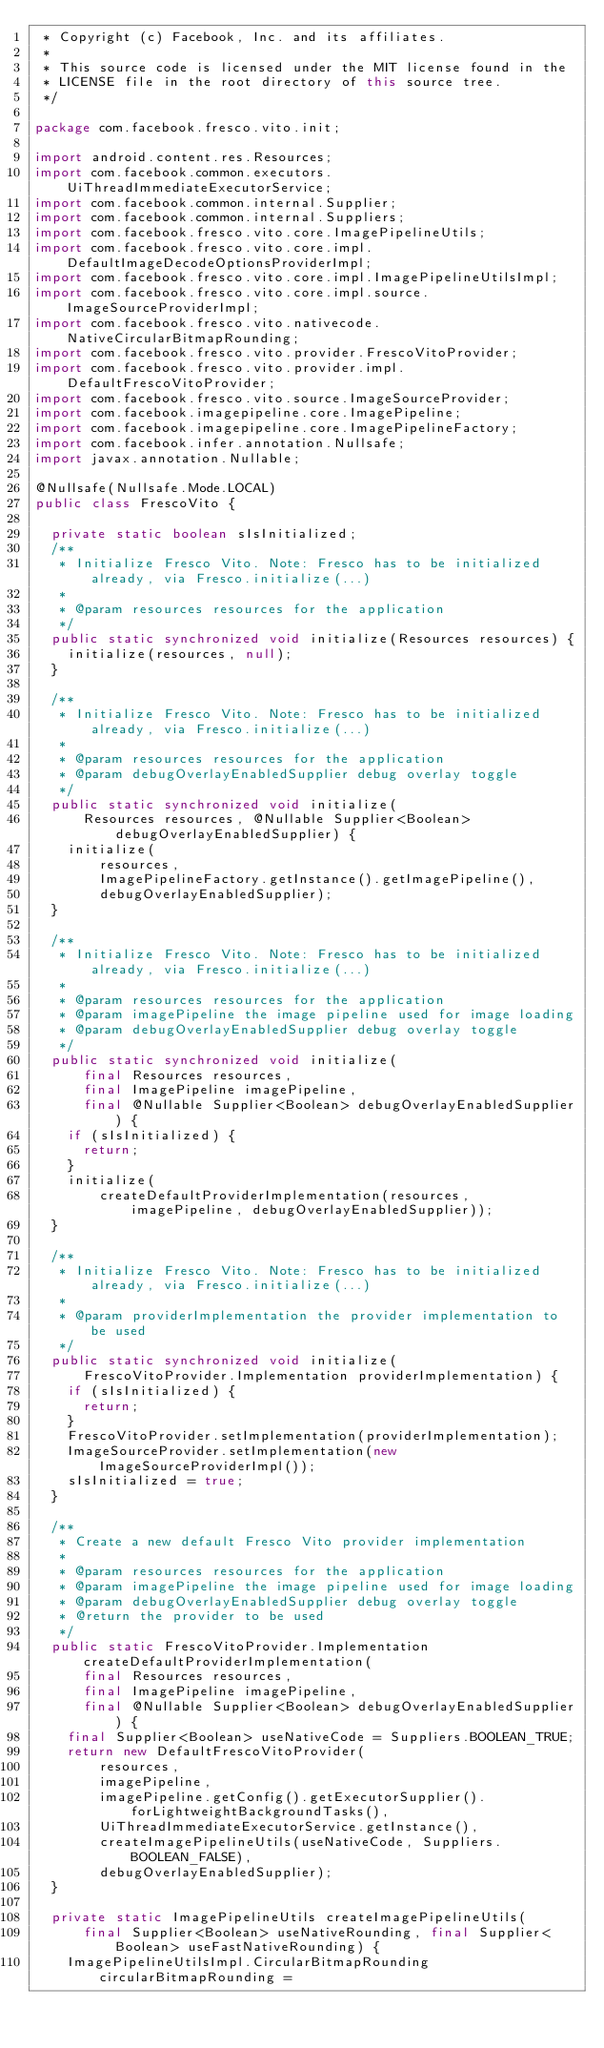<code> <loc_0><loc_0><loc_500><loc_500><_Java_> * Copyright (c) Facebook, Inc. and its affiliates.
 *
 * This source code is licensed under the MIT license found in the
 * LICENSE file in the root directory of this source tree.
 */

package com.facebook.fresco.vito.init;

import android.content.res.Resources;
import com.facebook.common.executors.UiThreadImmediateExecutorService;
import com.facebook.common.internal.Supplier;
import com.facebook.common.internal.Suppliers;
import com.facebook.fresco.vito.core.ImagePipelineUtils;
import com.facebook.fresco.vito.core.impl.DefaultImageDecodeOptionsProviderImpl;
import com.facebook.fresco.vito.core.impl.ImagePipelineUtilsImpl;
import com.facebook.fresco.vito.core.impl.source.ImageSourceProviderImpl;
import com.facebook.fresco.vito.nativecode.NativeCircularBitmapRounding;
import com.facebook.fresco.vito.provider.FrescoVitoProvider;
import com.facebook.fresco.vito.provider.impl.DefaultFrescoVitoProvider;
import com.facebook.fresco.vito.source.ImageSourceProvider;
import com.facebook.imagepipeline.core.ImagePipeline;
import com.facebook.imagepipeline.core.ImagePipelineFactory;
import com.facebook.infer.annotation.Nullsafe;
import javax.annotation.Nullable;

@Nullsafe(Nullsafe.Mode.LOCAL)
public class FrescoVito {

  private static boolean sIsInitialized;
  /**
   * Initialize Fresco Vito. Note: Fresco has to be initialized already, via Fresco.initialize(...)
   *
   * @param resources resources for the application
   */
  public static synchronized void initialize(Resources resources) {
    initialize(resources, null);
  }

  /**
   * Initialize Fresco Vito. Note: Fresco has to be initialized already, via Fresco.initialize(...)
   *
   * @param resources resources for the application
   * @param debugOverlayEnabledSupplier debug overlay toggle
   */
  public static synchronized void initialize(
      Resources resources, @Nullable Supplier<Boolean> debugOverlayEnabledSupplier) {
    initialize(
        resources,
        ImagePipelineFactory.getInstance().getImagePipeline(),
        debugOverlayEnabledSupplier);
  }

  /**
   * Initialize Fresco Vito. Note: Fresco has to be initialized already, via Fresco.initialize(...)
   *
   * @param resources resources for the application
   * @param imagePipeline the image pipeline used for image loading
   * @param debugOverlayEnabledSupplier debug overlay toggle
   */
  public static synchronized void initialize(
      final Resources resources,
      final ImagePipeline imagePipeline,
      final @Nullable Supplier<Boolean> debugOverlayEnabledSupplier) {
    if (sIsInitialized) {
      return;
    }
    initialize(
        createDefaultProviderImplementation(resources, imagePipeline, debugOverlayEnabledSupplier));
  }

  /**
   * Initialize Fresco Vito. Note: Fresco has to be initialized already, via Fresco.initialize(...)
   *
   * @param providerImplementation the provider implementation to be used
   */
  public static synchronized void initialize(
      FrescoVitoProvider.Implementation providerImplementation) {
    if (sIsInitialized) {
      return;
    }
    FrescoVitoProvider.setImplementation(providerImplementation);
    ImageSourceProvider.setImplementation(new ImageSourceProviderImpl());
    sIsInitialized = true;
  }

  /**
   * Create a new default Fresco Vito provider implementation
   *
   * @param resources resources for the application
   * @param imagePipeline the image pipeline used for image loading
   * @param debugOverlayEnabledSupplier debug overlay toggle
   * @return the provider to be used
   */
  public static FrescoVitoProvider.Implementation createDefaultProviderImplementation(
      final Resources resources,
      final ImagePipeline imagePipeline,
      final @Nullable Supplier<Boolean> debugOverlayEnabledSupplier) {
    final Supplier<Boolean> useNativeCode = Suppliers.BOOLEAN_TRUE;
    return new DefaultFrescoVitoProvider(
        resources,
        imagePipeline,
        imagePipeline.getConfig().getExecutorSupplier().forLightweightBackgroundTasks(),
        UiThreadImmediateExecutorService.getInstance(),
        createImagePipelineUtils(useNativeCode, Suppliers.BOOLEAN_FALSE),
        debugOverlayEnabledSupplier);
  }

  private static ImagePipelineUtils createImagePipelineUtils(
      final Supplier<Boolean> useNativeRounding, final Supplier<Boolean> useFastNativeRounding) {
    ImagePipelineUtilsImpl.CircularBitmapRounding circularBitmapRounding =</code> 